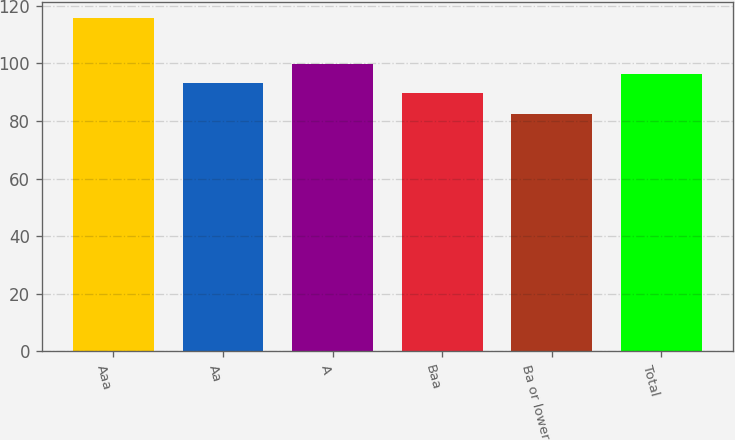Convert chart to OTSL. <chart><loc_0><loc_0><loc_500><loc_500><bar_chart><fcel>Aaa<fcel>Aa<fcel>A<fcel>Baa<fcel>Ba or lower<fcel>Total<nl><fcel>115.6<fcel>93.11<fcel>99.73<fcel>89.8<fcel>82.5<fcel>96.42<nl></chart> 